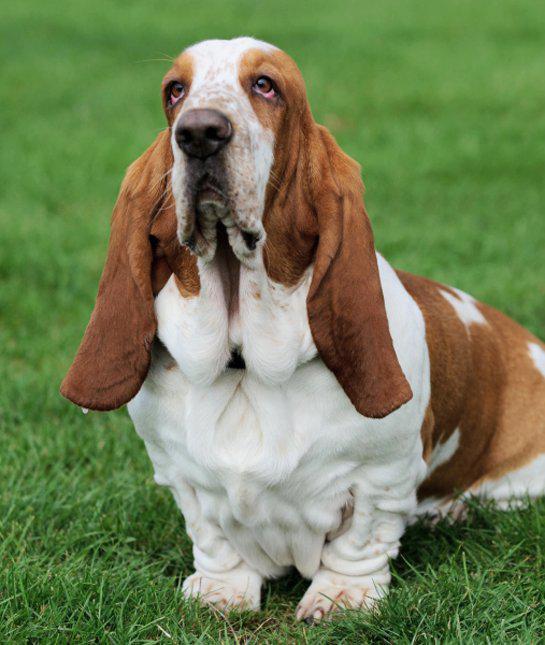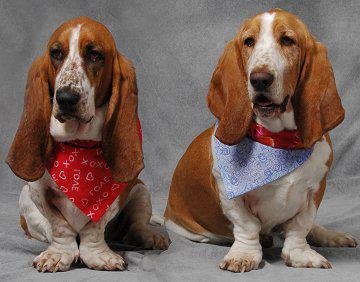The first image is the image on the left, the second image is the image on the right. Given the left and right images, does the statement "One image shows exactly two basset hounds." hold true? Answer yes or no. Yes. 